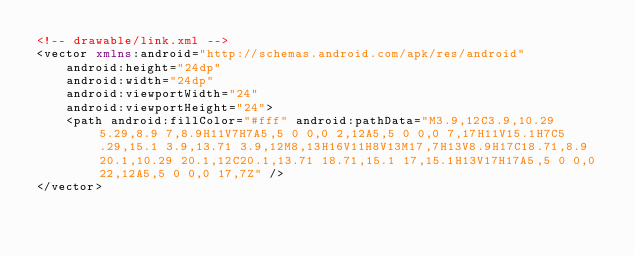<code> <loc_0><loc_0><loc_500><loc_500><_XML_><!-- drawable/link.xml -->
<vector xmlns:android="http://schemas.android.com/apk/res/android"
    android:height="24dp"
    android:width="24dp"
    android:viewportWidth="24"
    android:viewportHeight="24">
    <path android:fillColor="#fff" android:pathData="M3.9,12C3.9,10.29 5.29,8.9 7,8.9H11V7H7A5,5 0 0,0 2,12A5,5 0 0,0 7,17H11V15.1H7C5.29,15.1 3.9,13.71 3.9,12M8,13H16V11H8V13M17,7H13V8.9H17C18.71,8.9 20.1,10.29 20.1,12C20.1,13.71 18.71,15.1 17,15.1H13V17H17A5,5 0 0,0 22,12A5,5 0 0,0 17,7Z" />
</vector></code> 